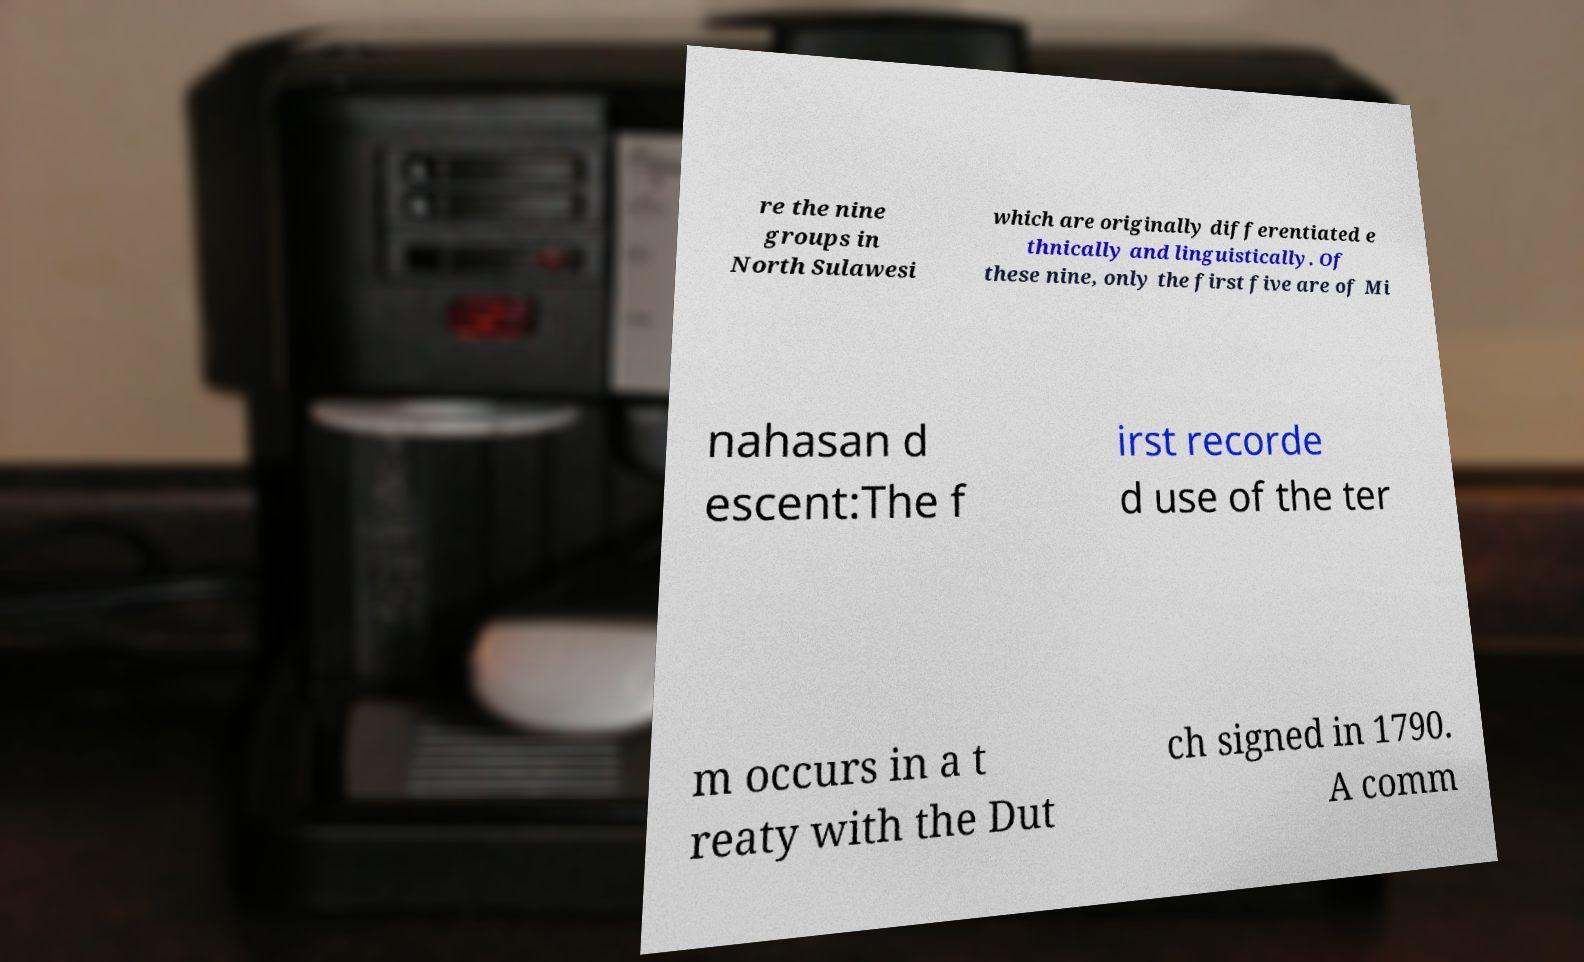Please identify and transcribe the text found in this image. re the nine groups in North Sulawesi which are originally differentiated e thnically and linguistically. Of these nine, only the first five are of Mi nahasan d escent:The f irst recorde d use of the ter m occurs in a t reaty with the Dut ch signed in 1790. A comm 